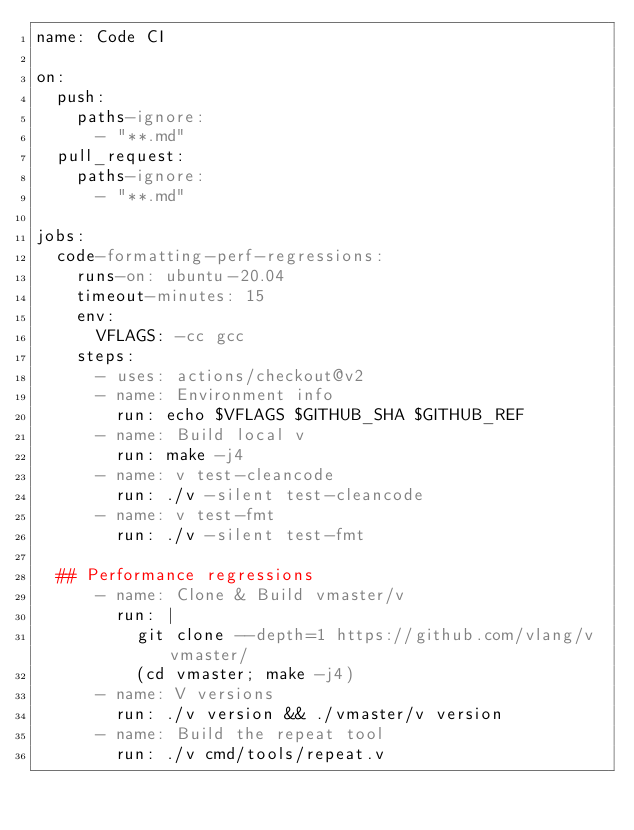<code> <loc_0><loc_0><loc_500><loc_500><_YAML_>name: Code CI

on:
  push:
    paths-ignore:
      - "**.md"
  pull_request:
    paths-ignore:
      - "**.md"

jobs:
  code-formatting-perf-regressions:
    runs-on: ubuntu-20.04
    timeout-minutes: 15
    env:
      VFLAGS: -cc gcc
    steps:
      - uses: actions/checkout@v2
      - name: Environment info
        run: echo $VFLAGS $GITHUB_SHA $GITHUB_REF
      - name: Build local v
        run: make -j4
      - name: v test-cleancode
        run: ./v -silent test-cleancode
      - name: v test-fmt
        run: ./v -silent test-fmt

  ## Performance regressions
      - name: Clone & Build vmaster/v
        run: |
          git clone --depth=1 https://github.com/vlang/v vmaster/
          (cd vmaster; make -j4)
      - name: V versions
        run: ./v version && ./vmaster/v version
      - name: Build the repeat tool
        run: ./v cmd/tools/repeat.v</code> 